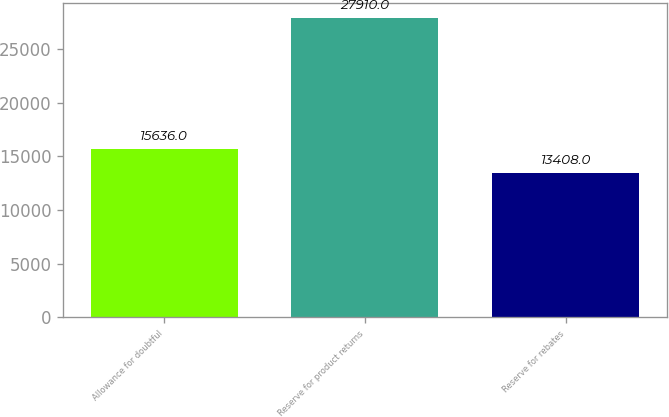<chart> <loc_0><loc_0><loc_500><loc_500><bar_chart><fcel>Allowance for doubtful<fcel>Reserve for product returns<fcel>Reserve for rebates<nl><fcel>15636<fcel>27910<fcel>13408<nl></chart> 